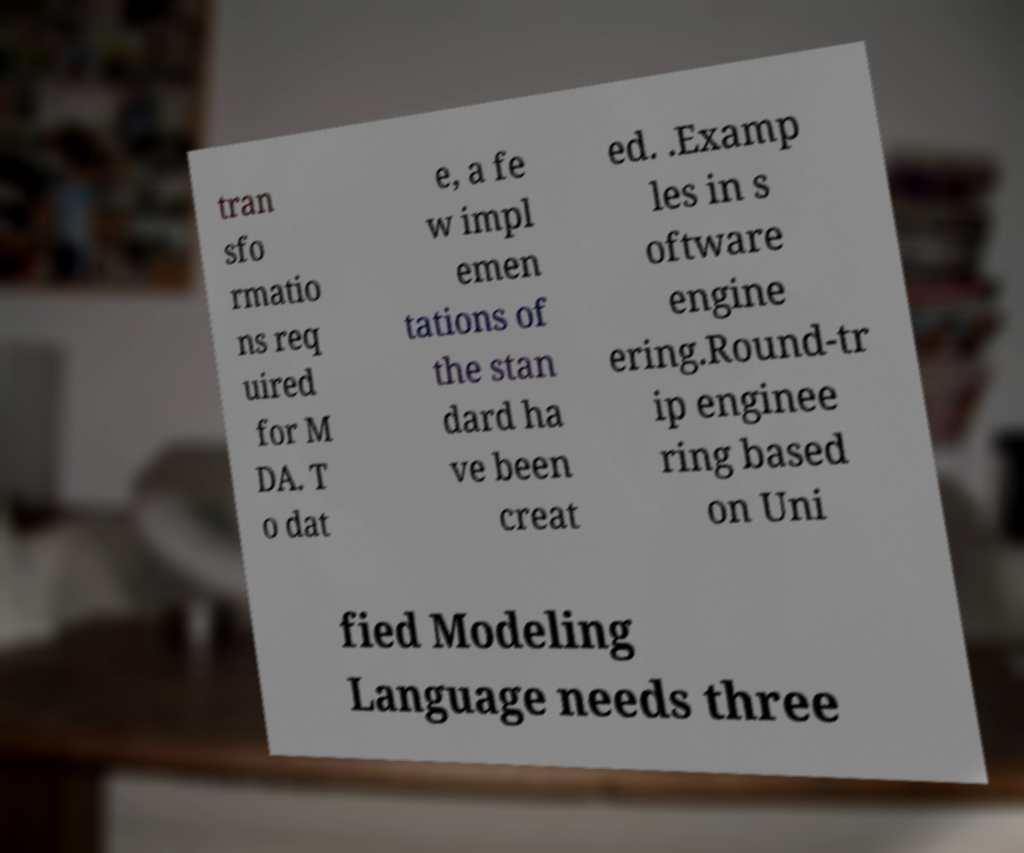Can you read and provide the text displayed in the image?This photo seems to have some interesting text. Can you extract and type it out for me? tran sfo rmatio ns req uired for M DA. T o dat e, a fe w impl emen tations of the stan dard ha ve been creat ed. .Examp les in s oftware engine ering.Round-tr ip enginee ring based on Uni fied Modeling Language needs three 